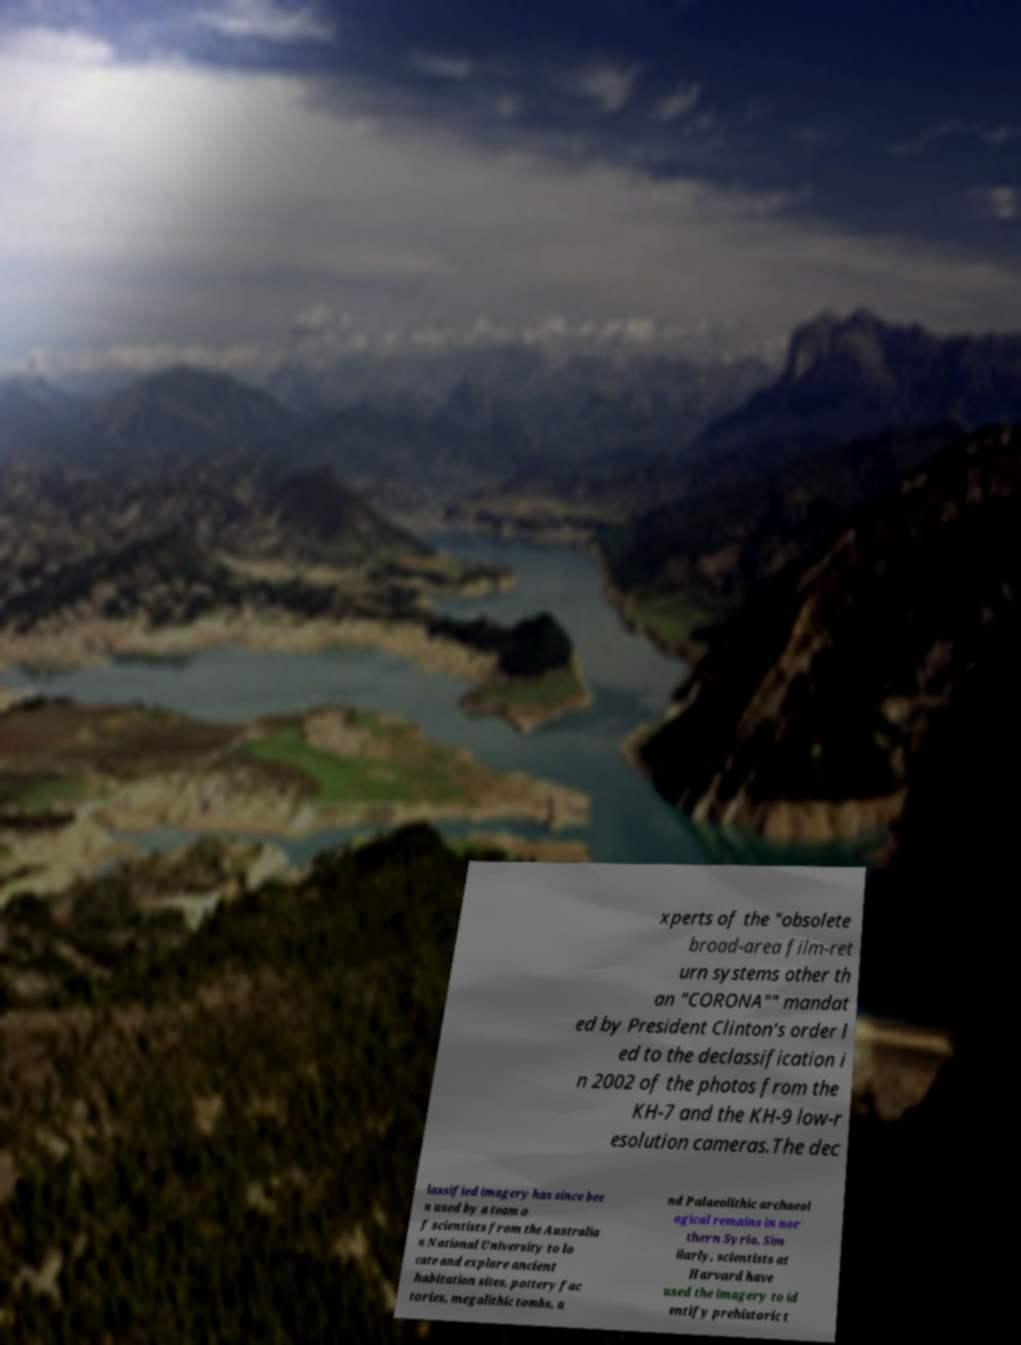Can you accurately transcribe the text from the provided image for me? xperts of the "obsolete broad-area film-ret urn systems other th an "CORONA"" mandat ed by President Clinton's order l ed to the declassification i n 2002 of the photos from the KH-7 and the KH-9 low-r esolution cameras.The dec lassified imagery has since bee n used by a team o f scientists from the Australia n National University to lo cate and explore ancient habitation sites, pottery fac tories, megalithic tombs, a nd Palaeolithic archaeol ogical remains in nor thern Syria. Sim ilarly, scientists at Harvard have used the imagery to id entify prehistoric t 